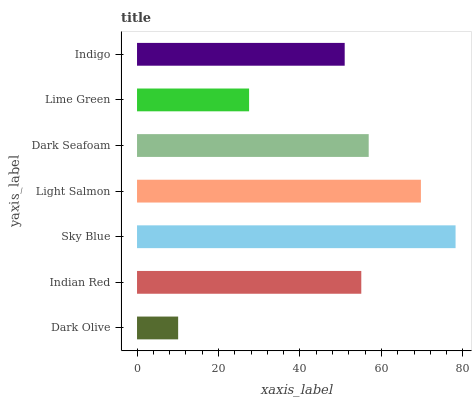Is Dark Olive the minimum?
Answer yes or no. Yes. Is Sky Blue the maximum?
Answer yes or no. Yes. Is Indian Red the minimum?
Answer yes or no. No. Is Indian Red the maximum?
Answer yes or no. No. Is Indian Red greater than Dark Olive?
Answer yes or no. Yes. Is Dark Olive less than Indian Red?
Answer yes or no. Yes. Is Dark Olive greater than Indian Red?
Answer yes or no. No. Is Indian Red less than Dark Olive?
Answer yes or no. No. Is Indian Red the high median?
Answer yes or no. Yes. Is Indian Red the low median?
Answer yes or no. Yes. Is Dark Olive the high median?
Answer yes or no. No. Is Lime Green the low median?
Answer yes or no. No. 